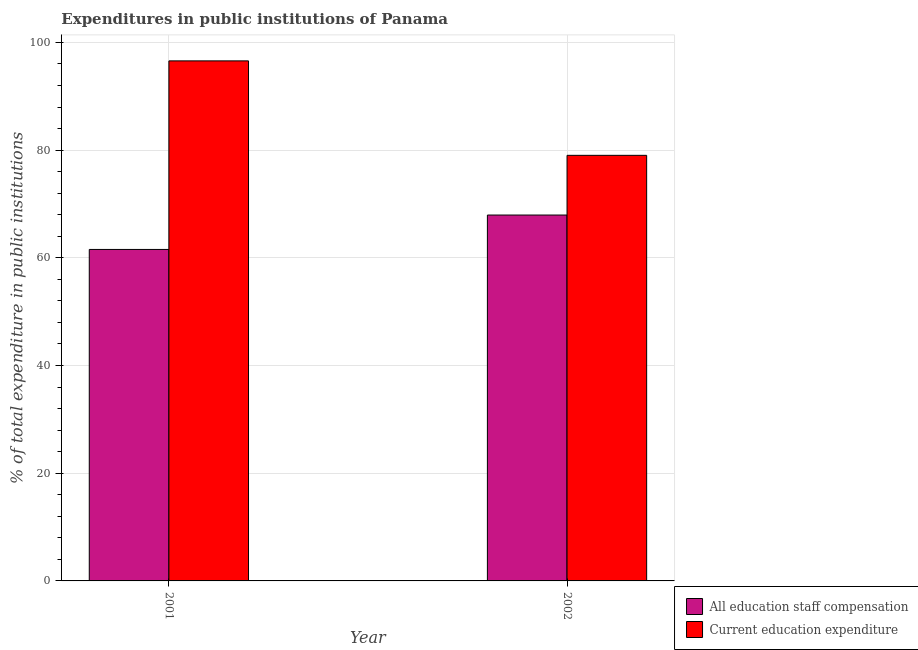How many different coloured bars are there?
Provide a succinct answer. 2. Are the number of bars per tick equal to the number of legend labels?
Your answer should be compact. Yes. Are the number of bars on each tick of the X-axis equal?
Ensure brevity in your answer.  Yes. How many bars are there on the 2nd tick from the left?
Your answer should be very brief. 2. What is the label of the 2nd group of bars from the left?
Offer a terse response. 2002. In how many cases, is the number of bars for a given year not equal to the number of legend labels?
Ensure brevity in your answer.  0. What is the expenditure in staff compensation in 2001?
Offer a very short reply. 61.55. Across all years, what is the maximum expenditure in staff compensation?
Ensure brevity in your answer.  67.94. Across all years, what is the minimum expenditure in staff compensation?
Your response must be concise. 61.55. In which year was the expenditure in education maximum?
Your response must be concise. 2001. What is the total expenditure in staff compensation in the graph?
Ensure brevity in your answer.  129.49. What is the difference between the expenditure in staff compensation in 2001 and that in 2002?
Ensure brevity in your answer.  -6.39. What is the difference between the expenditure in education in 2001 and the expenditure in staff compensation in 2002?
Give a very brief answer. 17.54. What is the average expenditure in education per year?
Offer a very short reply. 87.8. In the year 2001, what is the difference between the expenditure in staff compensation and expenditure in education?
Provide a short and direct response. 0. In how many years, is the expenditure in education greater than 44 %?
Ensure brevity in your answer.  2. What is the ratio of the expenditure in education in 2001 to that in 2002?
Your answer should be very brief. 1.22. Is the expenditure in education in 2001 less than that in 2002?
Offer a very short reply. No. In how many years, is the expenditure in education greater than the average expenditure in education taken over all years?
Provide a short and direct response. 1. What does the 2nd bar from the left in 2001 represents?
Your answer should be very brief. Current education expenditure. What does the 1st bar from the right in 2002 represents?
Provide a short and direct response. Current education expenditure. Are the values on the major ticks of Y-axis written in scientific E-notation?
Give a very brief answer. No. Does the graph contain grids?
Your answer should be very brief. Yes. What is the title of the graph?
Offer a very short reply. Expenditures in public institutions of Panama. Does "Female entrants" appear as one of the legend labels in the graph?
Make the answer very short. No. What is the label or title of the Y-axis?
Give a very brief answer. % of total expenditure in public institutions. What is the % of total expenditure in public institutions of All education staff compensation in 2001?
Ensure brevity in your answer.  61.55. What is the % of total expenditure in public institutions in Current education expenditure in 2001?
Offer a very short reply. 96.57. What is the % of total expenditure in public institutions in All education staff compensation in 2002?
Keep it short and to the point. 67.94. What is the % of total expenditure in public institutions in Current education expenditure in 2002?
Ensure brevity in your answer.  79.03. Across all years, what is the maximum % of total expenditure in public institutions of All education staff compensation?
Your answer should be compact. 67.94. Across all years, what is the maximum % of total expenditure in public institutions in Current education expenditure?
Keep it short and to the point. 96.57. Across all years, what is the minimum % of total expenditure in public institutions of All education staff compensation?
Offer a terse response. 61.55. Across all years, what is the minimum % of total expenditure in public institutions of Current education expenditure?
Your answer should be very brief. 79.03. What is the total % of total expenditure in public institutions in All education staff compensation in the graph?
Your response must be concise. 129.49. What is the total % of total expenditure in public institutions in Current education expenditure in the graph?
Give a very brief answer. 175.6. What is the difference between the % of total expenditure in public institutions of All education staff compensation in 2001 and that in 2002?
Give a very brief answer. -6.39. What is the difference between the % of total expenditure in public institutions in Current education expenditure in 2001 and that in 2002?
Ensure brevity in your answer.  17.54. What is the difference between the % of total expenditure in public institutions in All education staff compensation in 2001 and the % of total expenditure in public institutions in Current education expenditure in 2002?
Provide a succinct answer. -17.48. What is the average % of total expenditure in public institutions in All education staff compensation per year?
Give a very brief answer. 64.75. What is the average % of total expenditure in public institutions in Current education expenditure per year?
Your response must be concise. 87.8. In the year 2001, what is the difference between the % of total expenditure in public institutions in All education staff compensation and % of total expenditure in public institutions in Current education expenditure?
Make the answer very short. -35.02. In the year 2002, what is the difference between the % of total expenditure in public institutions in All education staff compensation and % of total expenditure in public institutions in Current education expenditure?
Your answer should be very brief. -11.09. What is the ratio of the % of total expenditure in public institutions of All education staff compensation in 2001 to that in 2002?
Offer a terse response. 0.91. What is the ratio of the % of total expenditure in public institutions of Current education expenditure in 2001 to that in 2002?
Offer a terse response. 1.22. What is the difference between the highest and the second highest % of total expenditure in public institutions in All education staff compensation?
Give a very brief answer. 6.39. What is the difference between the highest and the second highest % of total expenditure in public institutions of Current education expenditure?
Your answer should be compact. 17.54. What is the difference between the highest and the lowest % of total expenditure in public institutions in All education staff compensation?
Offer a terse response. 6.39. What is the difference between the highest and the lowest % of total expenditure in public institutions of Current education expenditure?
Your answer should be very brief. 17.54. 